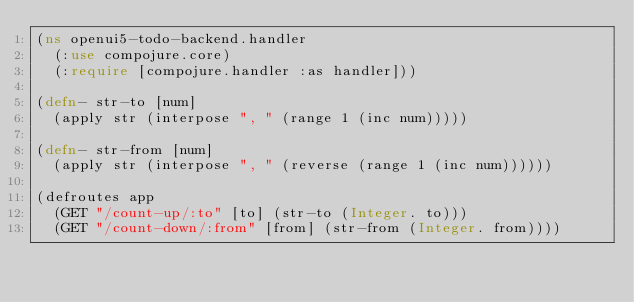Convert code to text. <code><loc_0><loc_0><loc_500><loc_500><_Clojure_>(ns openui5-todo-backend.handler
	(:use compojure.core)
	(:require [compojure.handler :as handler]))

(defn- str-to [num]
	(apply str (interpose ", " (range 1 (inc num)))))

(defn- str-from [num]
	(apply str (interpose ", " (reverse (range 1 (inc num))))))

(defroutes app
	(GET "/count-up/:to" [to] (str-to (Integer. to)))
	(GET "/count-down/:from" [from] (str-from (Integer. from))))</code> 